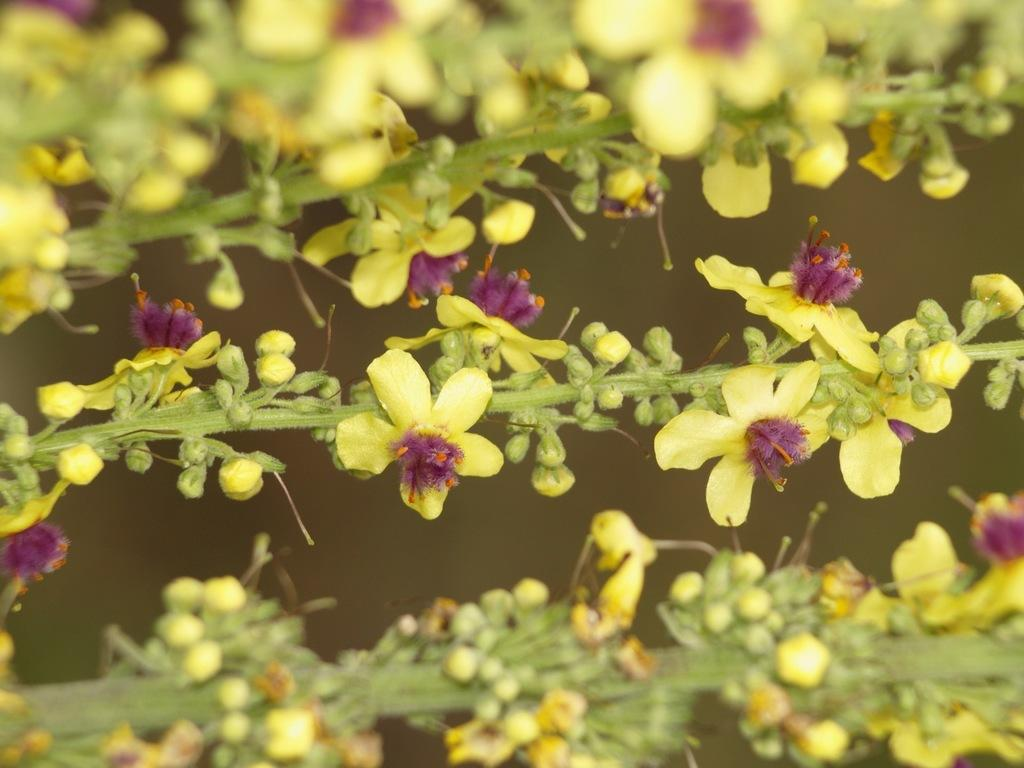What is the main subject of the image? There is a plant in the center of the image. What can be observed about the plant? The plant has flowers. What colors are the flowers? The flowers are in yellow and pink colors. What type of insurance policy is being advertised by the plant in the image? There is no insurance policy being advertised in the image; it features a plant with yellow and pink flowers. Can you describe the taste of the plant's tongue in the image? Plants do not have tongues, so this question cannot be answered. 